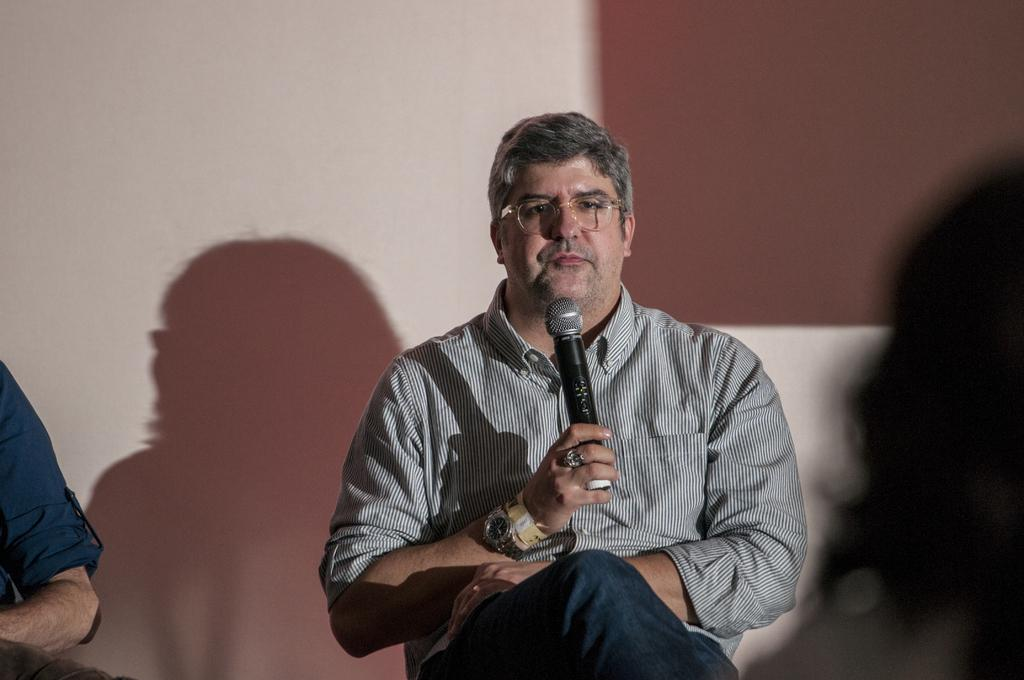What is there is a person sitting in a chair in the image, what are they doing? The person is holding a microphone. Can you describe the setting of the image? There is another person in the background of the image. What is the weight of the egg on the person's head in the image? There is no egg present on the person's head in the image. 